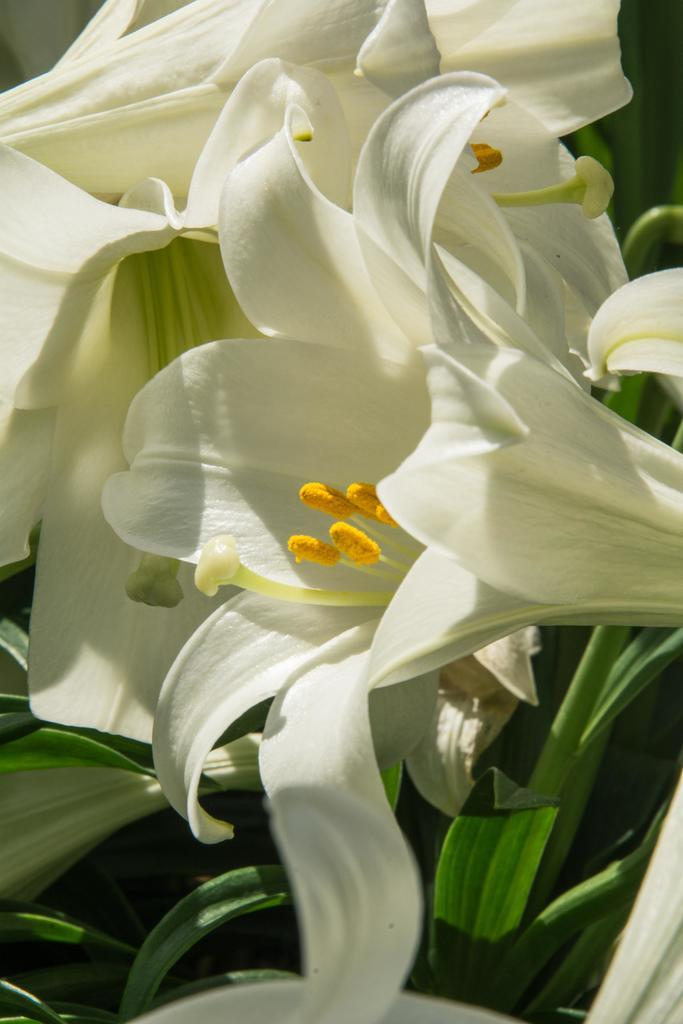What type of living organisms can be seen in the image? Plants can be seen in the image. What color are the flowers on the plants? The flowers on the plants are white. What sound can be heard coming from the plants in the image? There is no sound coming from the plants in the image, as plants do not produce sounds. 